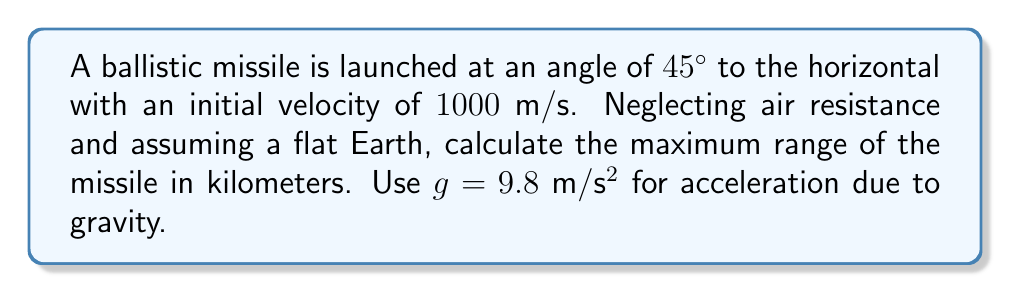Teach me how to tackle this problem. Let's approach this step-by-step:

1) The range of a projectile launched at an angle $\theta$ with initial velocity $v_0$ is given by the formula:

   $$R = \frac{v_0^2 \sin(2\theta)}{g}$$

2) We're given:
   - $\theta = 45°$
   - $v_0 = 1000$ m/s
   - $g = 9.8$ m/s²

3) First, let's calculate $\sin(2\theta)$:
   $$\sin(2 \cdot 45°) = \sin(90°) = 1$$

4) Now we can substitute all values into our range equation:

   $$R = \frac{(1000 \text{ m/s})^2 \cdot 1}{9.8 \text{ m/s}^2}$$

5) Simplify:
   $$R = \frac{1,000,000 \text{ m}^2/\text{s}^2}{9.8 \text{ m/s}^2} = 102,040.82 \text{ m}$$

6) Convert to kilometers:
   $$R = 102.04 \text{ km}$$

Thus, the maximum range of the missile is approximately 102.04 km.
Answer: 102.04 km 